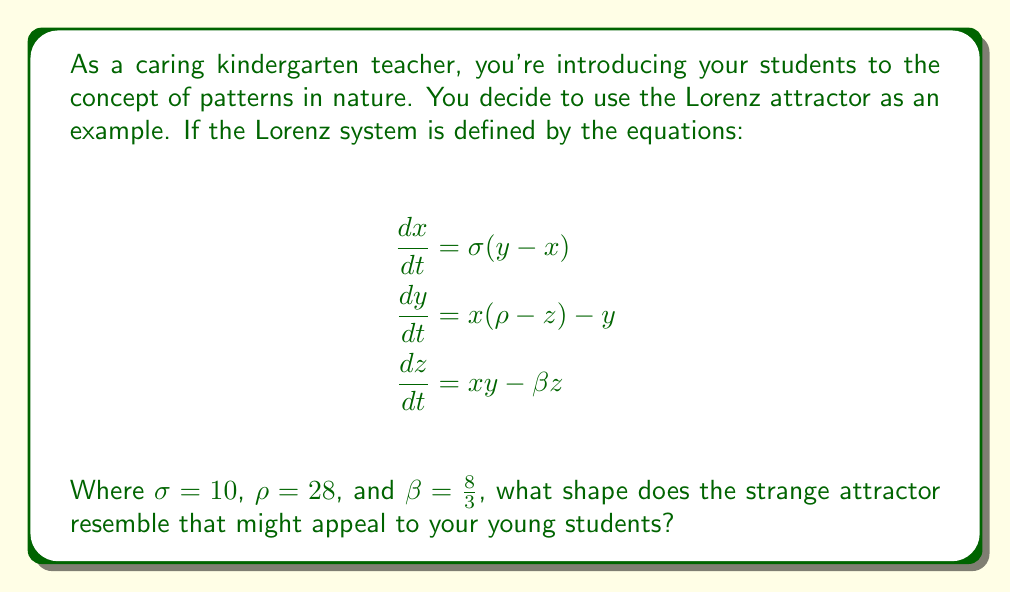Give your solution to this math problem. To answer this question, we need to understand the behavior of the Lorenz system and visualize its strange attractor:

1. The Lorenz system is a set of three coupled, nonlinear differential equations that describe atmospheric convection.

2. When we plot the solutions to these equations in three-dimensional space (with x, y, and z as the axes), we get a trajectory that never repeats itself exactly but stays within a bounded region.

3. This bounded region forms a shape known as the Lorenz attractor.

4. To visualize the attractor, we can use numerical methods to solve the equations and plot the results. This is typically done using computer simulations.

5. The resulting shape has two main lobes that the trajectory alternates between in an unpredictable pattern.

6. When viewed from certain angles, this shape resembles a butterfly with its wings spread.

7. The butterfly-like shape of the Lorenz attractor is often used as a simple visual representation of chaos theory, as it demonstrates how complex patterns can arise from relatively simple equations.

8. For kindergarten students, the butterfly shape is an appealing and recognizable form that can help introduce the idea of patterns in nature, even if they don't understand the underlying mathematics.
Answer: Butterfly 